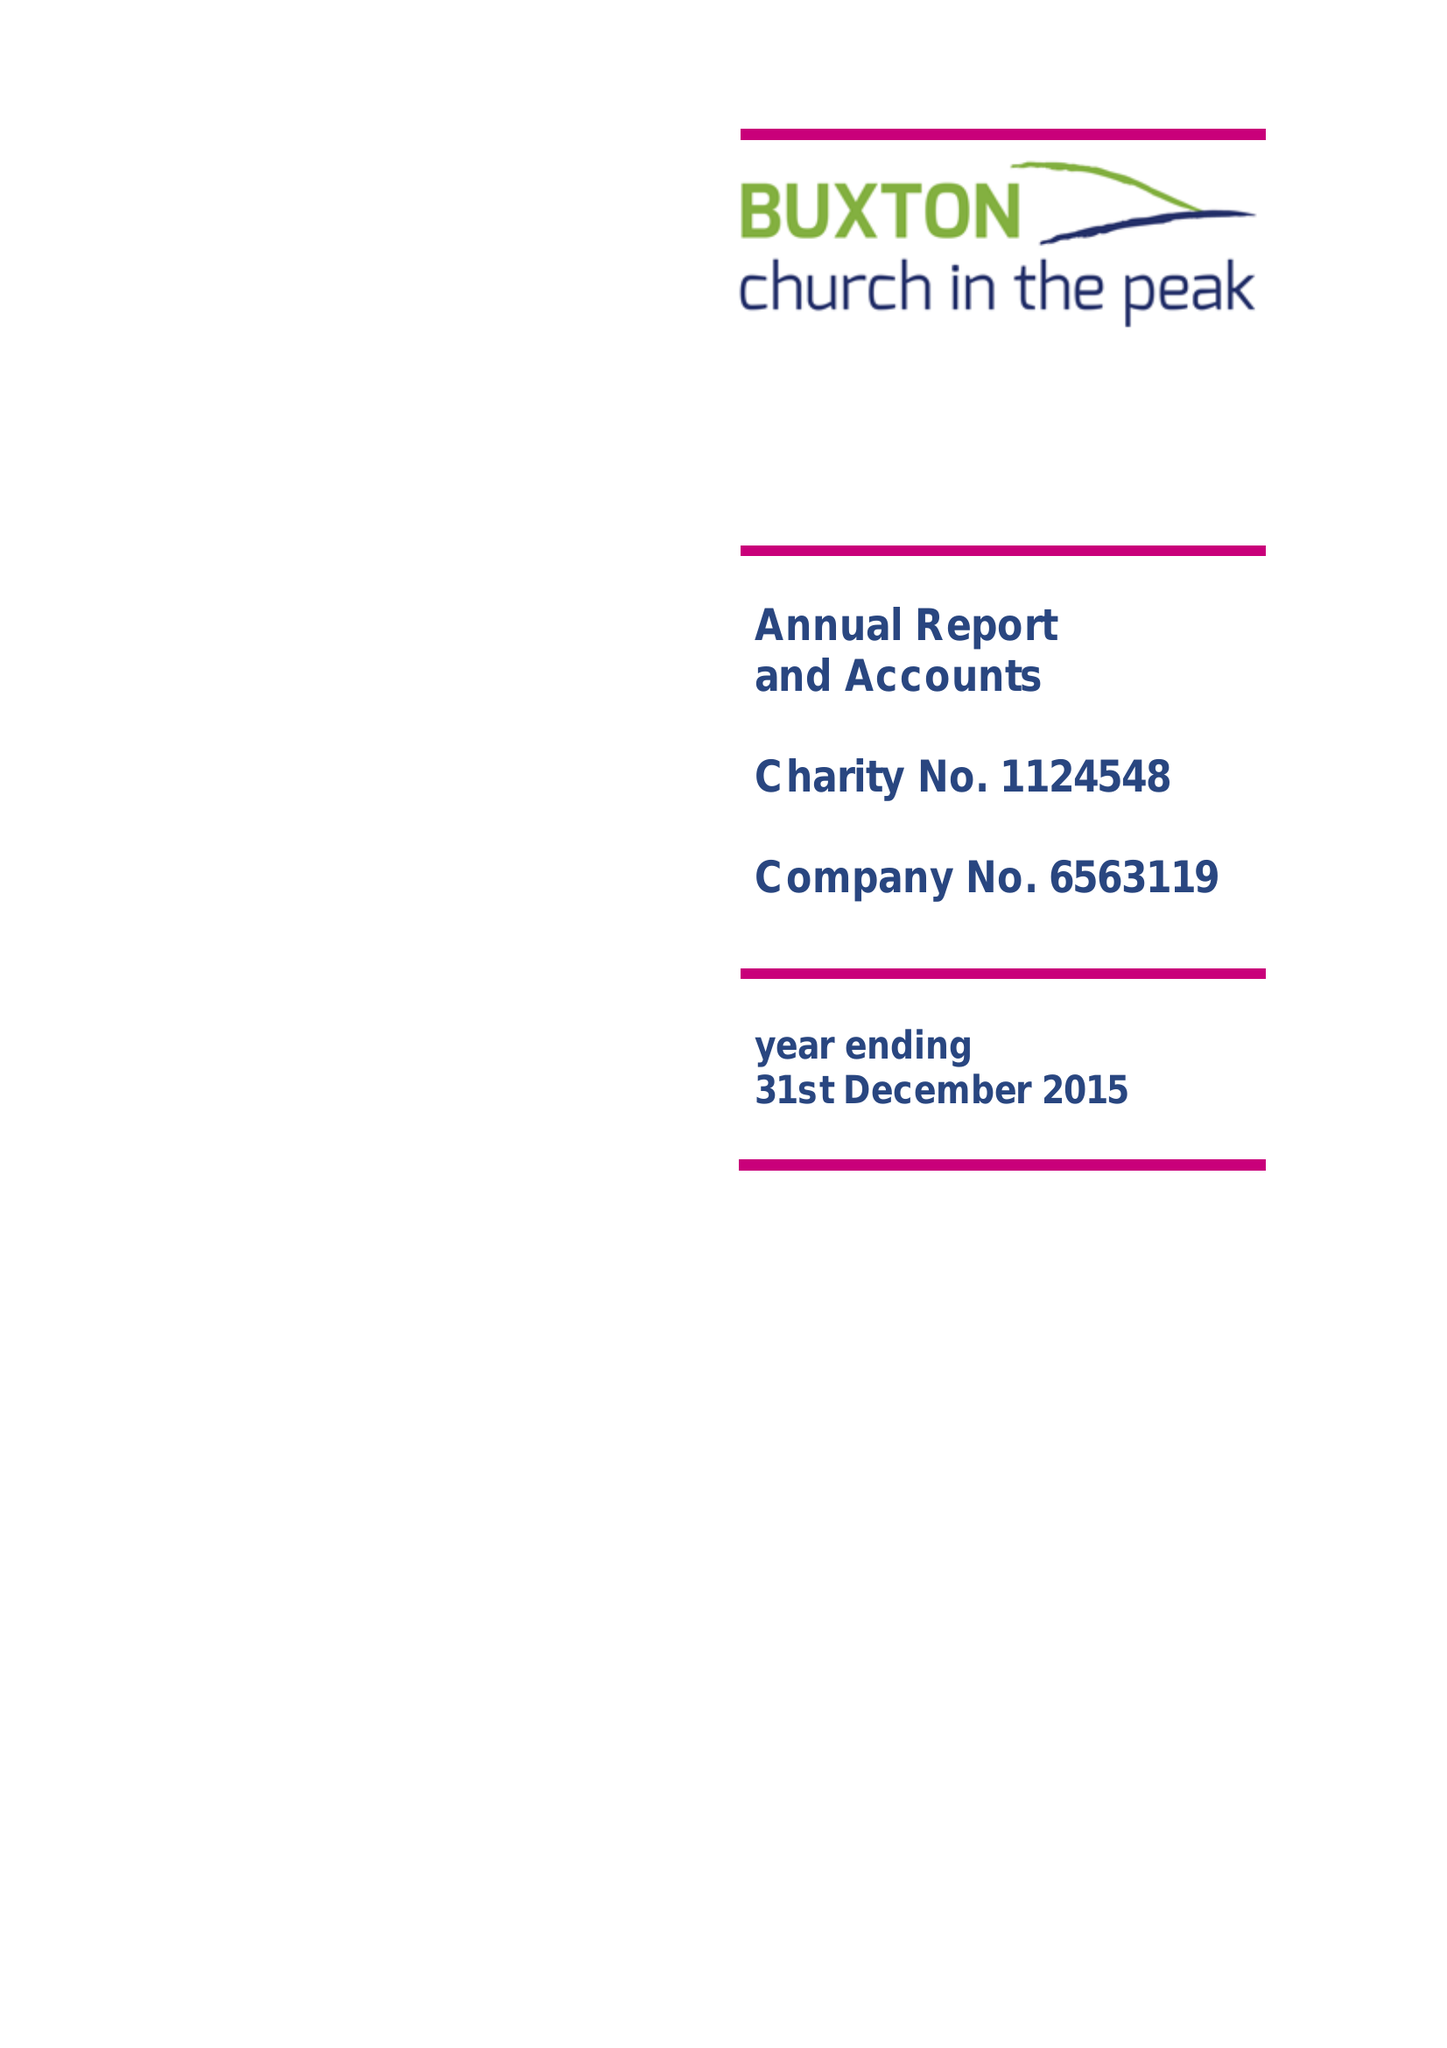What is the value for the address__street_line?
Answer the question using a single word or phrase. 116 MACCLESFIELD ROAD 